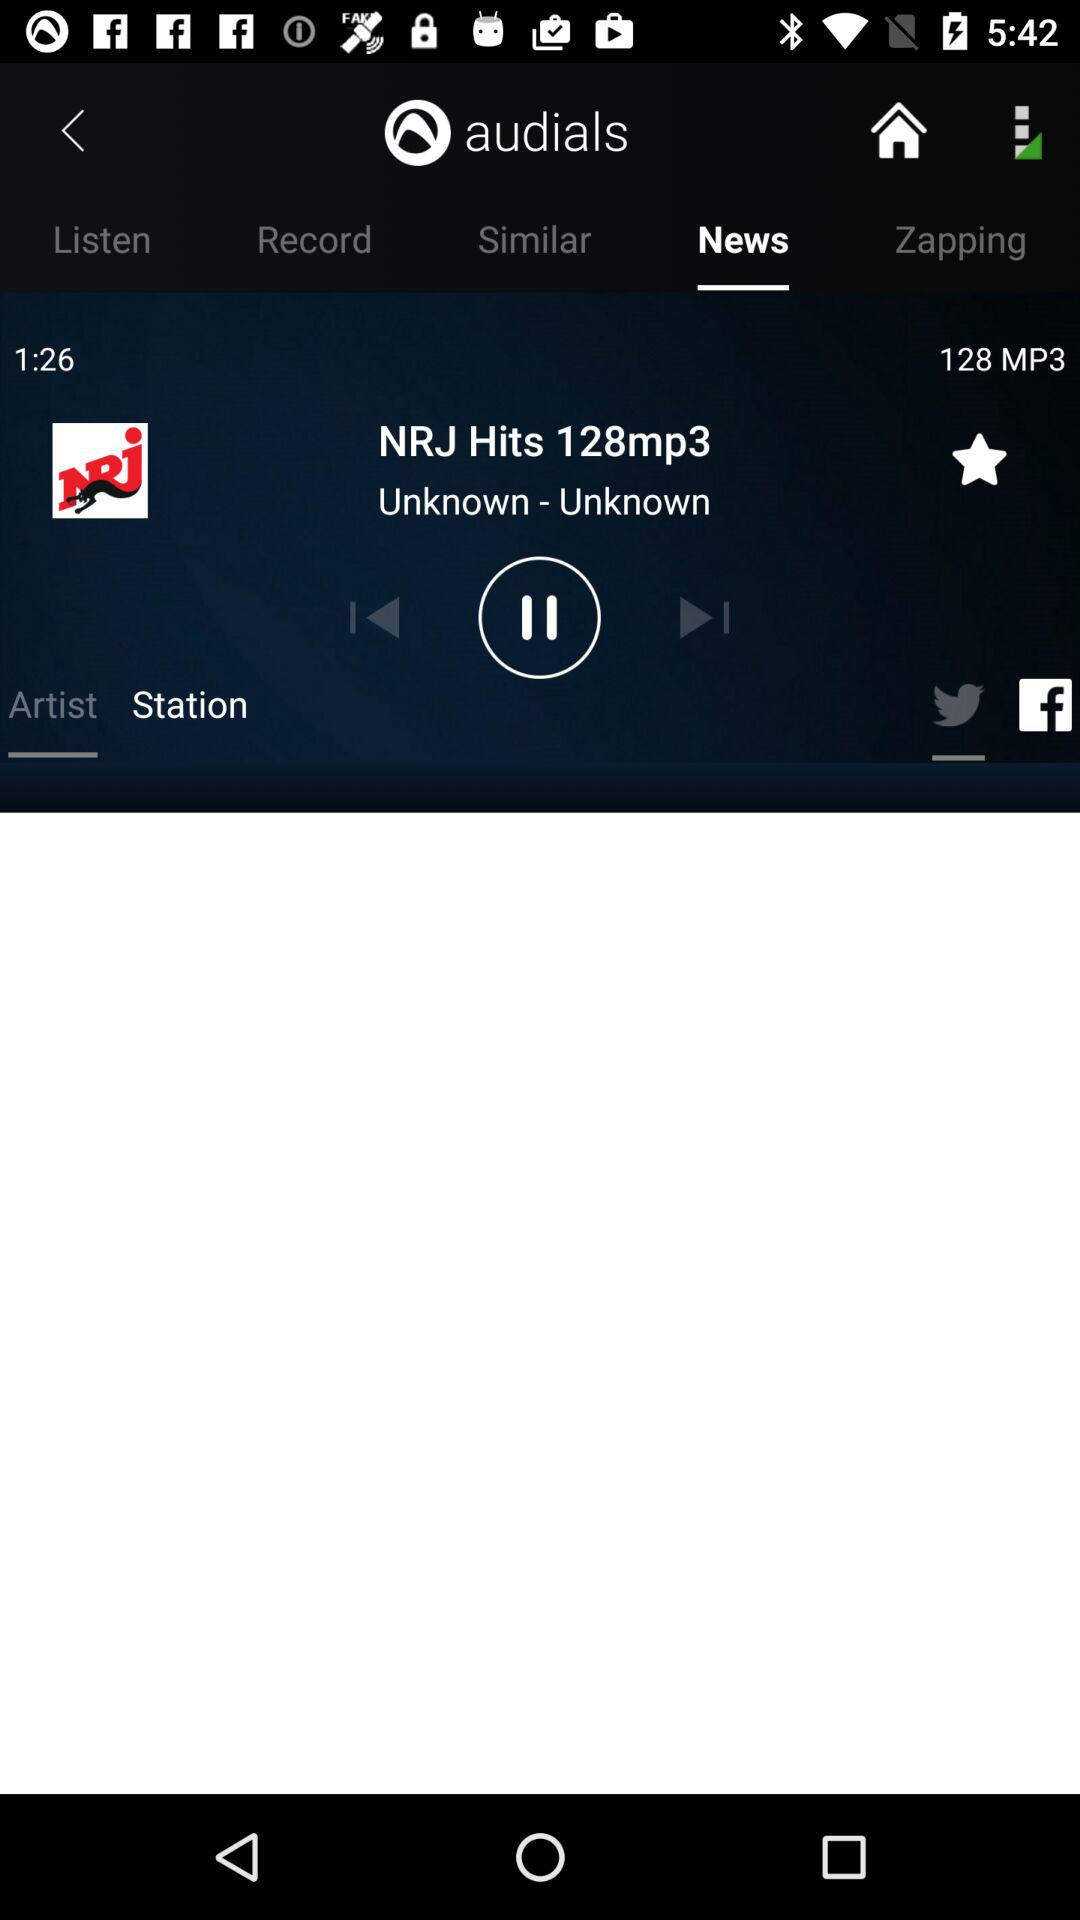Which tab is selected? The selected tab is "News". 